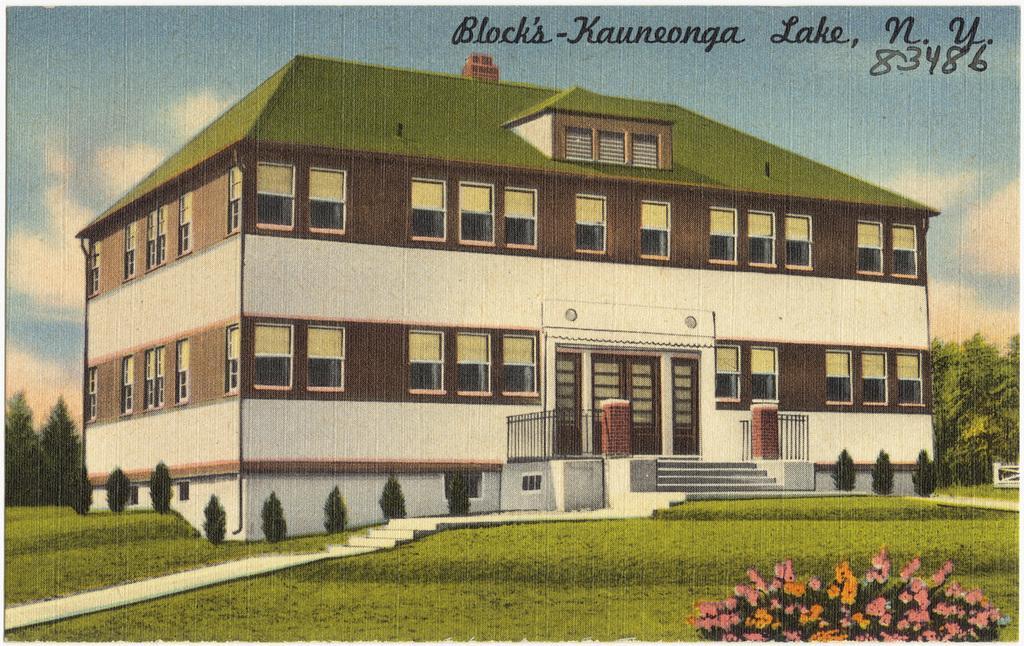Can you describe this image briefly? In the foreground of this image, there is grassland, stairs, trees, flowers, a building, sky and the cloud are depicted. At the top, there is some text. 